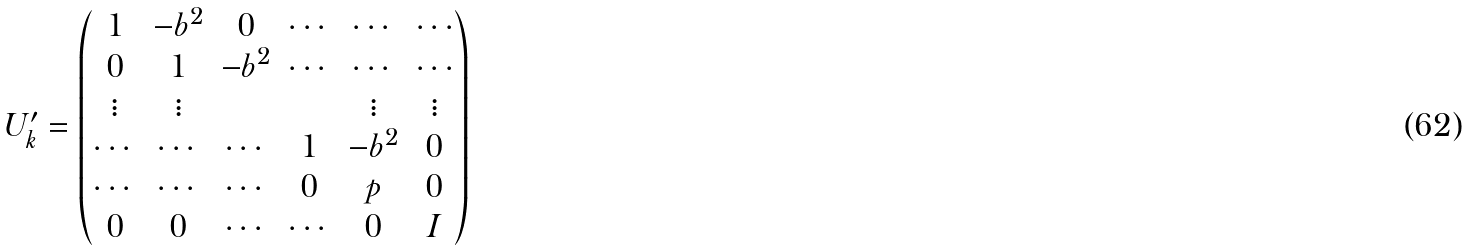<formula> <loc_0><loc_0><loc_500><loc_500>U _ { k } ^ { \prime } = \begin{pmatrix} 1 & - b ^ { 2 } & 0 & \cdots & \cdots & \cdots \\ 0 & 1 & - b ^ { 2 } & \cdots & \cdots & \cdots \\ \vdots & \vdots & & & \vdots & \vdots \\ \cdots & \cdots & \cdots & 1 & - b ^ { 2 } & 0 \\ \cdots & \cdots & \cdots & 0 & p & 0 \\ 0 & 0 & \cdots & \cdots & 0 & I \end{pmatrix}</formula> 